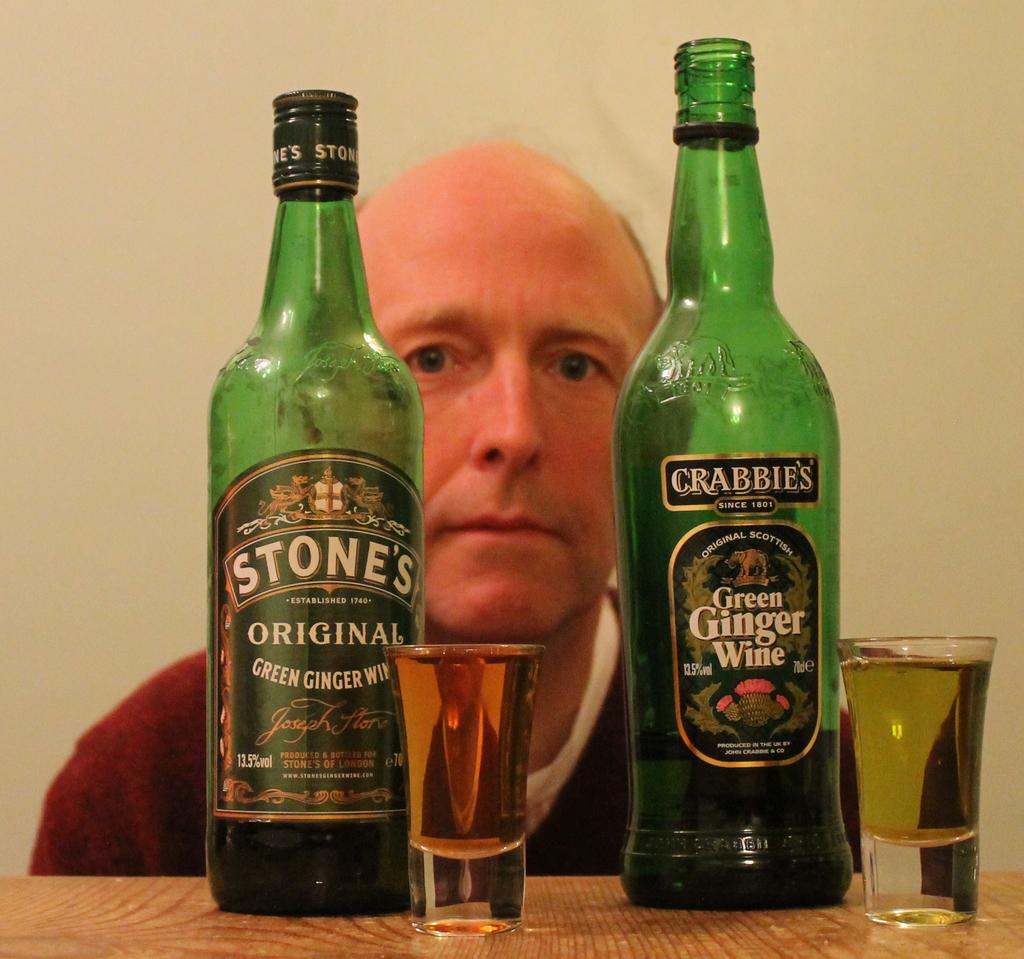What type of liquor is on the right?
Offer a terse response. Green ginger wine. What brand is on the left?
Offer a very short reply. Stones. 